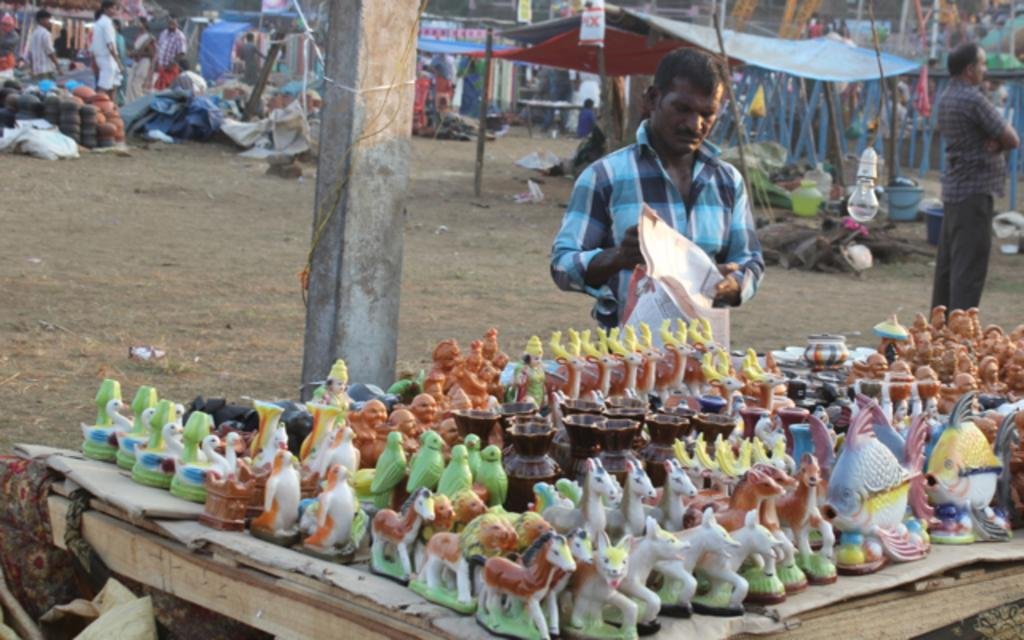What is the person in the image doing? The person in the image is selling idols. What type of idols are being sold? The idols are of various animals. How are the idols being sold? The idols are being sold on a cart. What can be seen in the background of the image? There are many people walking in the background. What type of location does the scene appear to be? The scene appears to be an air flea market. How does the person selling idols breathe while working at the flea market? The image does not provide information about the person's breathing, so it cannot be determined from the image. 